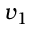<formula> <loc_0><loc_0><loc_500><loc_500>v _ { 1 }</formula> 